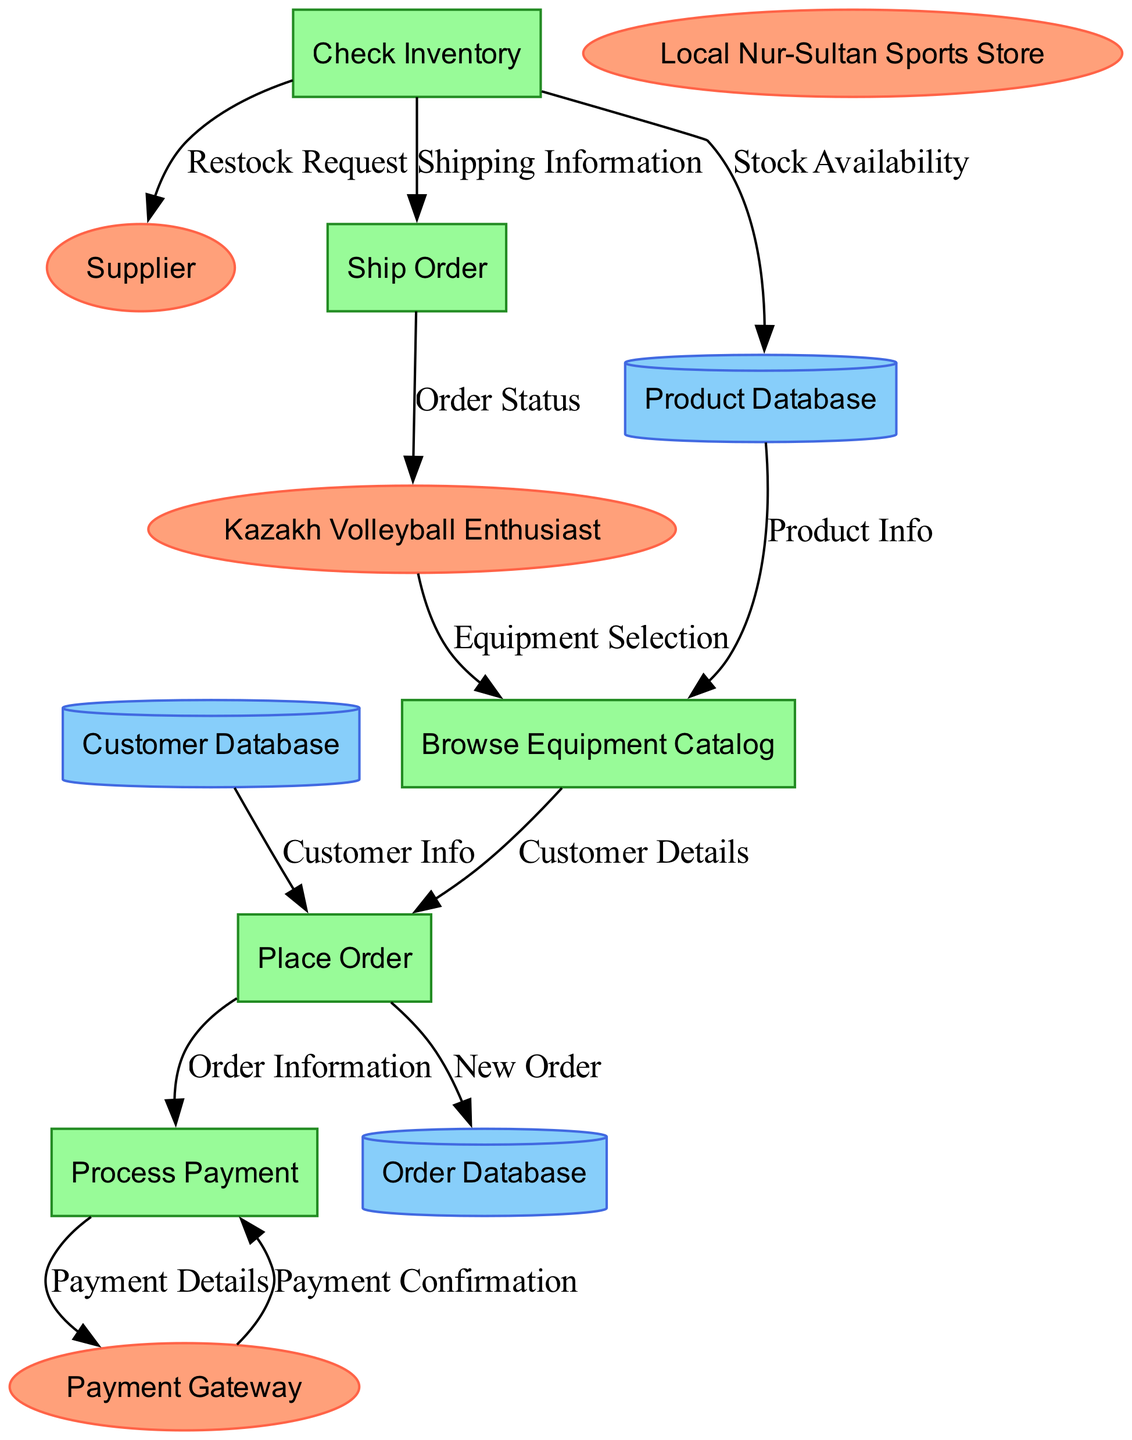What are the external entities in the diagram? The external entities listed are "Kazakh Volleyball Enthusiast," "Local Nur-Sultan Sports Store," "Payment Gateway," and "Supplier." These entities are represented as the oval-shaped nodes in the diagram.
Answer: Kazakh Volleyball Enthusiast, Local Nur-Sultan Sports Store, Payment Gateway, Supplier How many processes are outlined in the diagram? The number of processes in the diagram is indicated by the rectangular nodes. There are five processes: "Browse Equipment Catalog," "Place Order," "Process Payment," "Check Inventory," and "Ship Order." Thus, the total is five.
Answer: 5 What is the data flow from "Place Order" to "Process Payment"? The data flow between these two processes involves "Order Information" being sent from the "Place Order" process to the "Process Payment" process. This is depicted by an arrow connecting the two nodes with the label.
Answer: Order Information Which process checks the inventory? The process that checks the inventory is labeled as "Check Inventory." This process is specifically designated in the diagram to monitor product availability.
Answer: Check Inventory What data store is connected to the "Ship Order" process? The data store connected to the "Ship Order" process is not explicitly mentioned in the diagram but inferred from the connections. However, the "Order Database" is the one that is updated or used during this process.
Answer: Order Database Which external entity receives the "Shipping Information"? The "Kazakh Volleyball Enthusiast" is the external entity that receives the "Shipping Information" after the order is processed and shipped. The flow of data indicates this output direction.
Answer: Kazakh Volleyball Enthusiast What is the last data flow in the process? The last data flow in the process, as depicted, is "Order Status," which is sent back to the "Kazakh Volleyball Enthusiast" after the order has been processed and shipped. This is shown as the final arrow in the diagram.
Answer: Order Status How many data stores are present in the diagram? The data stores are represented as cylinder-shaped nodes in the diagram. There are three data stores indicated: "Product Database," "Customer Database," and "Order Database." Thus, the total count is three.
Answer: 3 What is the purpose of the "Payment Gateway" in the diagram? The "Payment Gateway" serves as an intermediary in the payment process, receiving "Payment Details" and providing "Payment Confirmation," facilitating the secure transaction. This role is depicted in the flow from "Process Payment" to "Payment Gateway."
Answer: Intermediary for secure transactions 